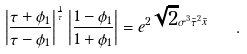Convert formula to latex. <formula><loc_0><loc_0><loc_500><loc_500>\left | \frac { \tau + \phi _ { 1 } } { \tau - \phi _ { 1 } } \right | ^ { \frac { 1 } { \tau } } \left | \frac { 1 - \phi _ { 1 } } { 1 + \phi _ { 1 } } \right | = e ^ { 2 \sqrt { 2 } \sigma ^ { 3 } \bar { \tau } ^ { 2 } \bar { x } } \quad .</formula> 